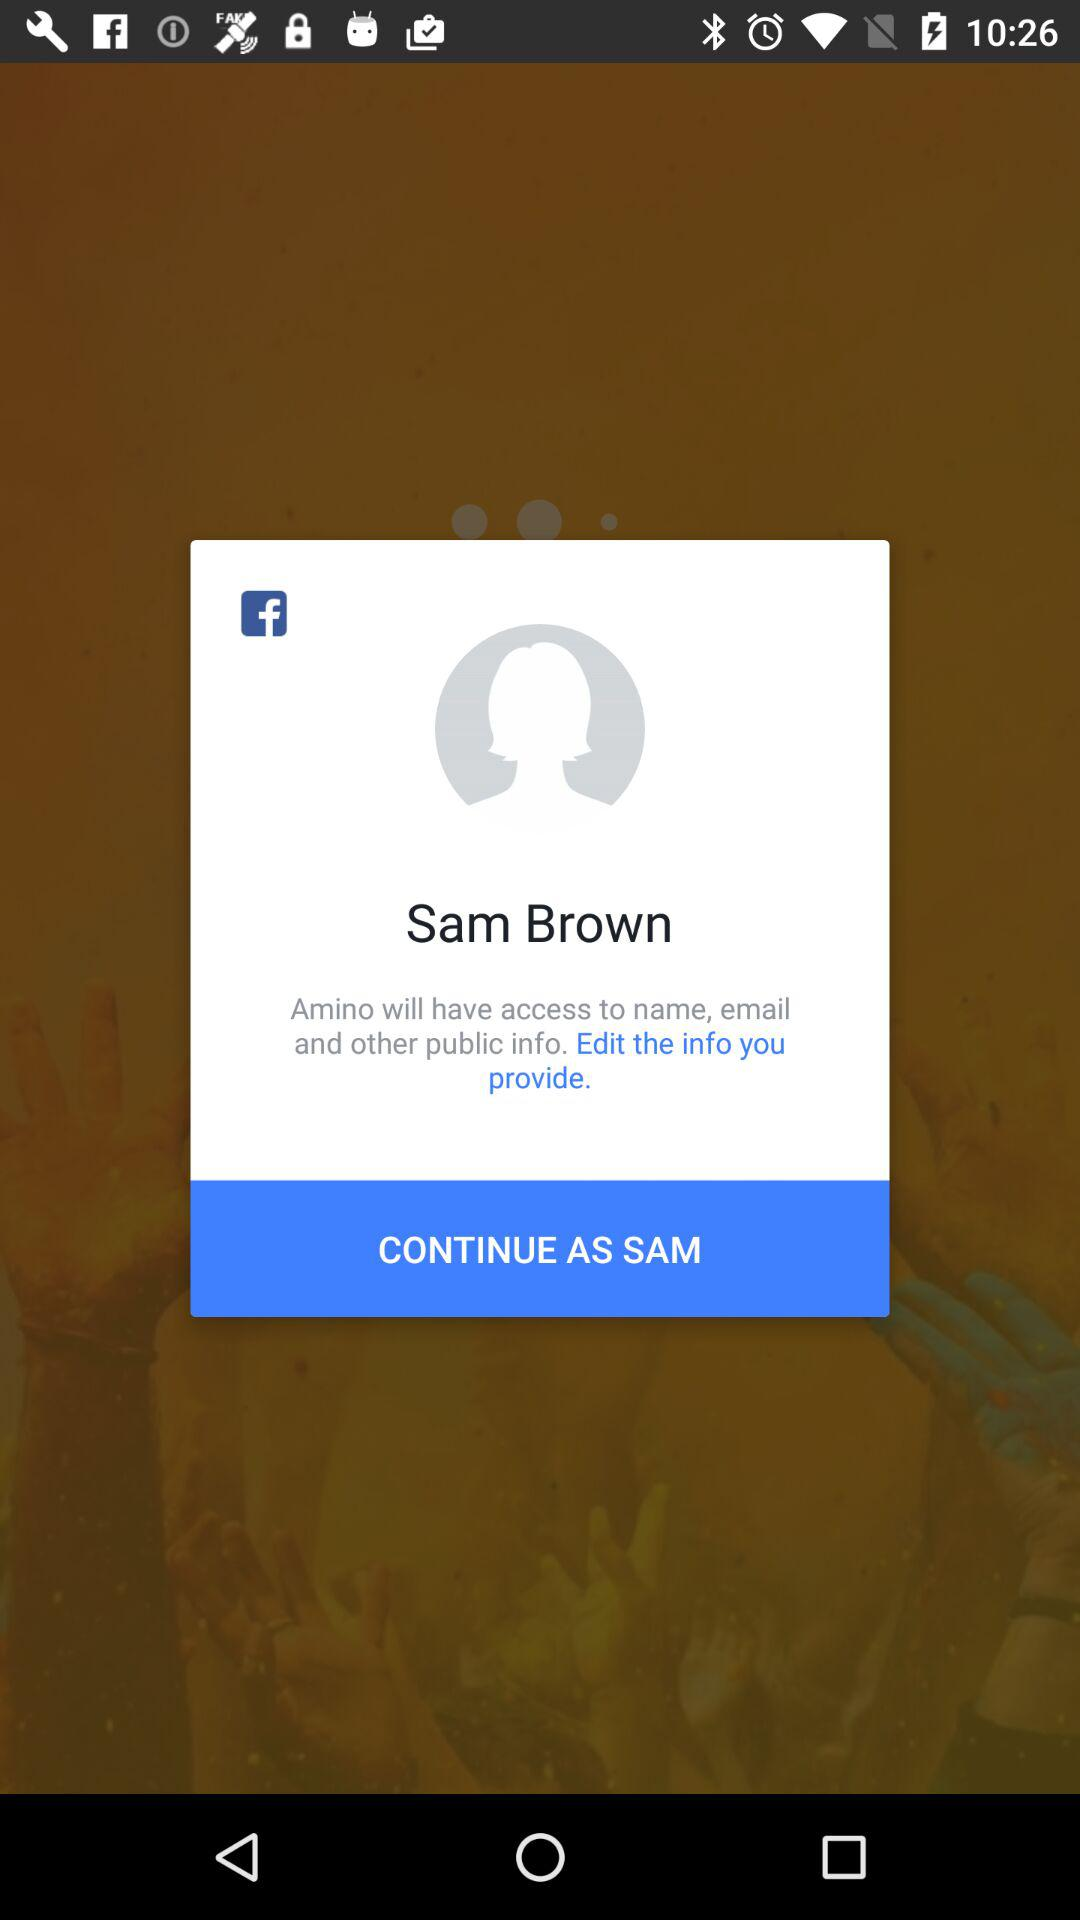Is the information provided edited?
When the provided information is insufficient, respond with <no answer>. <no answer> 